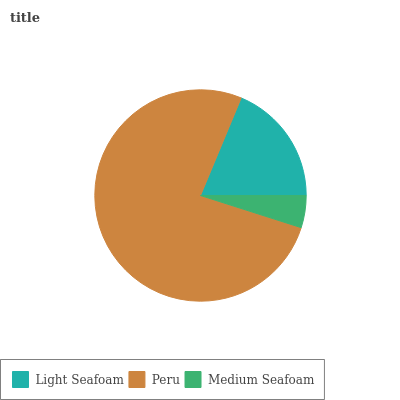Is Medium Seafoam the minimum?
Answer yes or no. Yes. Is Peru the maximum?
Answer yes or no. Yes. Is Peru the minimum?
Answer yes or no. No. Is Medium Seafoam the maximum?
Answer yes or no. No. Is Peru greater than Medium Seafoam?
Answer yes or no. Yes. Is Medium Seafoam less than Peru?
Answer yes or no. Yes. Is Medium Seafoam greater than Peru?
Answer yes or no. No. Is Peru less than Medium Seafoam?
Answer yes or no. No. Is Light Seafoam the high median?
Answer yes or no. Yes. Is Light Seafoam the low median?
Answer yes or no. Yes. Is Peru the high median?
Answer yes or no. No. Is Medium Seafoam the low median?
Answer yes or no. No. 